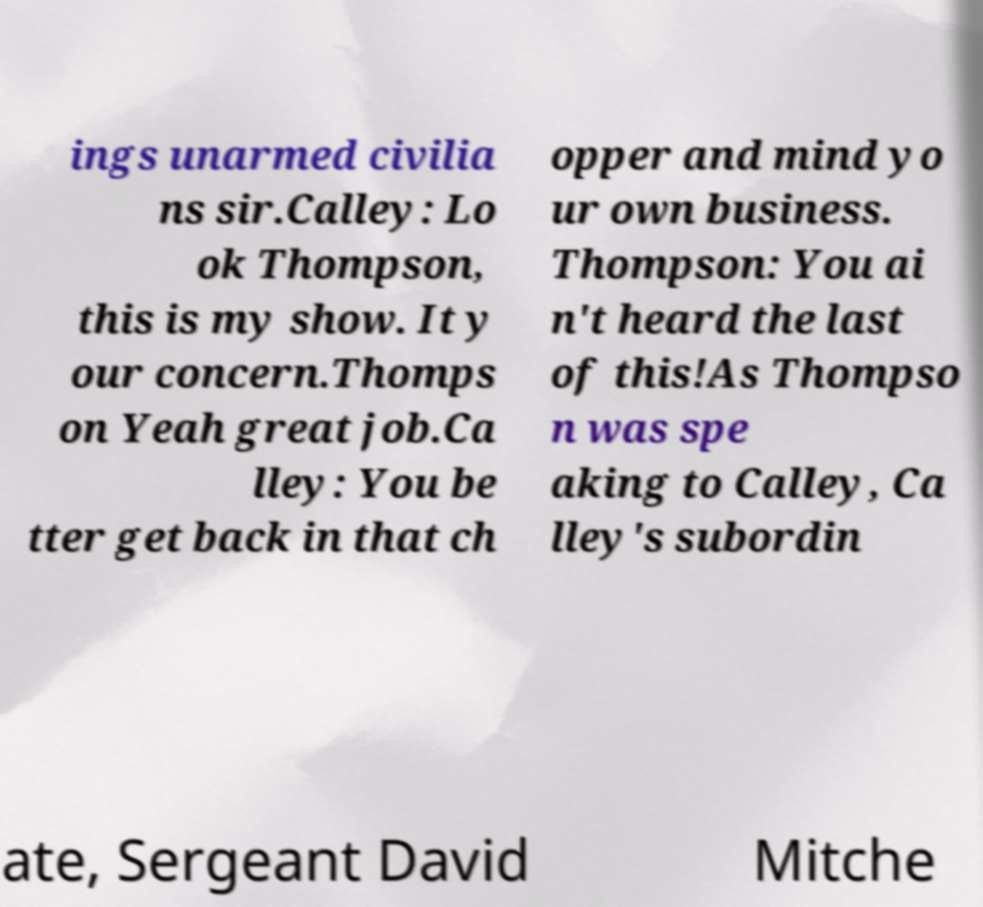Please identify and transcribe the text found in this image. ings unarmed civilia ns sir.Calley: Lo ok Thompson, this is my show. It y our concern.Thomps on Yeah great job.Ca lley: You be tter get back in that ch opper and mind yo ur own business. Thompson: You ai n't heard the last of this!As Thompso n was spe aking to Calley, Ca lley's subordin ate, Sergeant David Mitche 